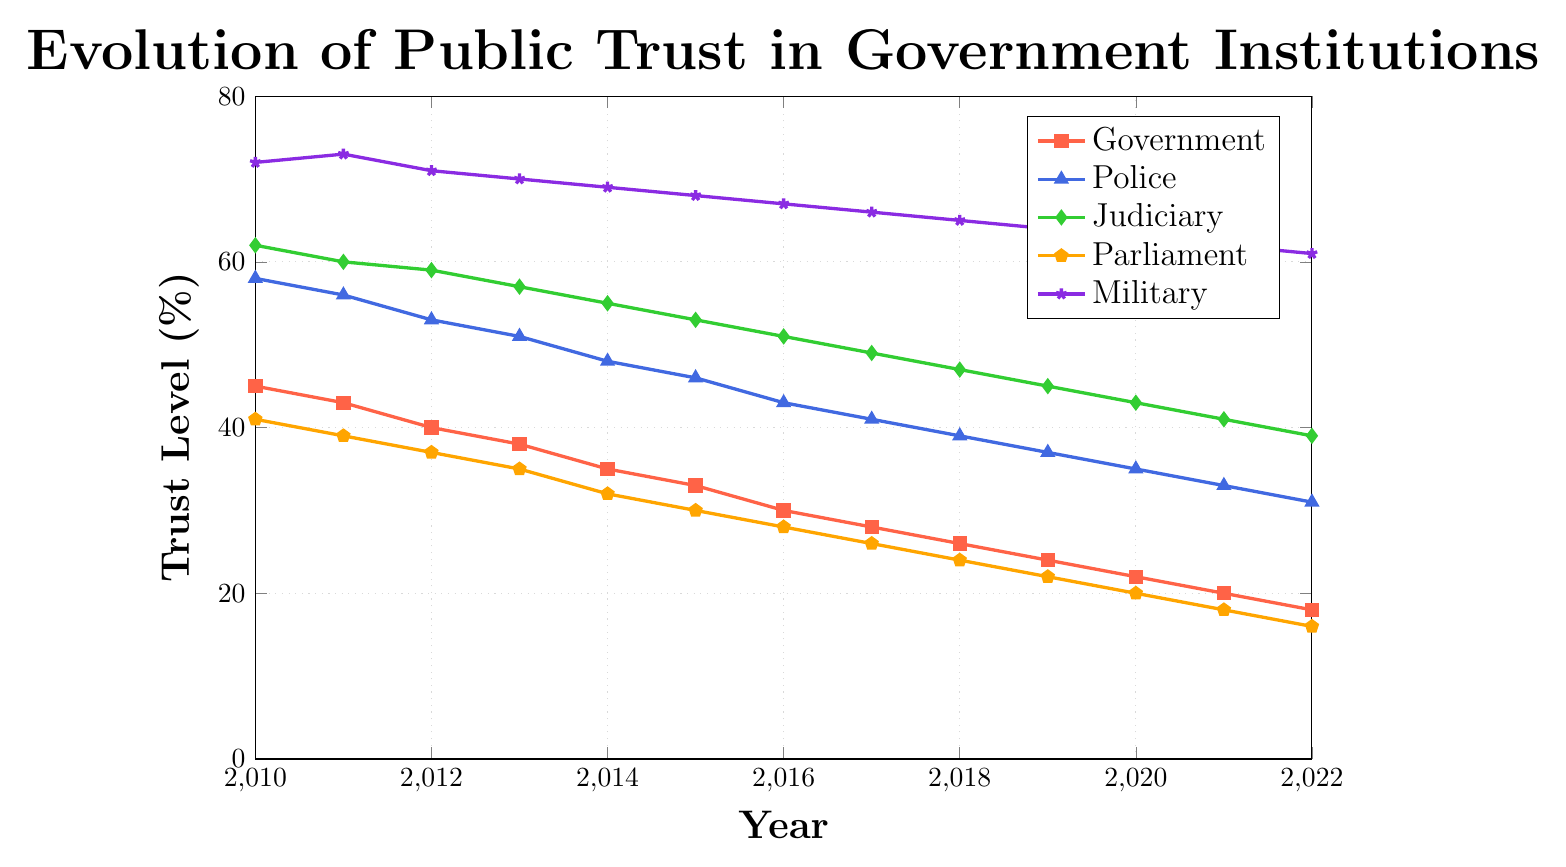What is the trust level for the Judiciary in 2017? The data for the Judiciary's trust level in 2017 can be found by looking up the corresponding point on the line for the Judiciary on the graph in 2017. The value is 49.
Answer: 49 How much did trust in the Government decrease from 2010 to 2022? To find the decrease in trust for the Government from 2010 to 2022, subtract the trust level in 2022 from the trust level in 2010: 45 - 18 = 27.
Answer: 27 Which institution had the highest trust level in 2015? By looking at the graph for the year 2015, the highest trust level is given by the institution with the highest point. The Military had the highest trust level at 68.
Answer: Military What is the average trust level for the Police from 2015 to 2018? To calculate the average trust level for the Police from 2015 to 2018, sum the trust levels for those years and divide by the number of years: (46 + 43 + 41 + 39) / 4 = 169 / 4 = 42.25.
Answer: 42.25 Which institutions experienced a continuous decrease in trust from 2010 to 2022? By examining each line on the graph from 2010 to 2022, the institutions with a continuous downward trend are the Government, Police, Judiciary, and Parliament.
Answer: Government, Police, Judiciary, Parliament In which year did the trust in Parliament drop below 30%? By following the graph for Parliament, the trust level dropped below 30% in the year 2016.
Answer: 2016 How did trust in the Military change between 2010 and 2012? The trust level in the Military was 72 in 2010 and 71 in 2012. The change is calculated as 71 - 72 = -1, indicating a decrease of 1.
Answer: Decreased by 1 Compare the trust levels of the Police and Judiciary in the year 2020. Which was higher and by how much? The trust levels for 2020 are 35 for the Police and 43 for the Judiciary. The difference is 43 - 35 = 8, with the Judiciary being higher.
Answer: Judiciary by 8 What is the median trust level for Parliament from 2010 to 2022? To find the median trust level, list the trust levels in ascending order: [16, 18, 20, 22, 24, 26, 28, 30, 32, 35, 37, 39, 41]. The median is the middle value, which is 28.
Answer: 28 